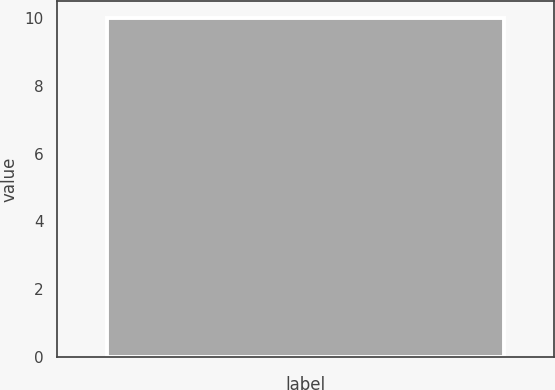Convert chart. <chart><loc_0><loc_0><loc_500><loc_500><bar_chart><ecel><nl><fcel>10<nl></chart> 